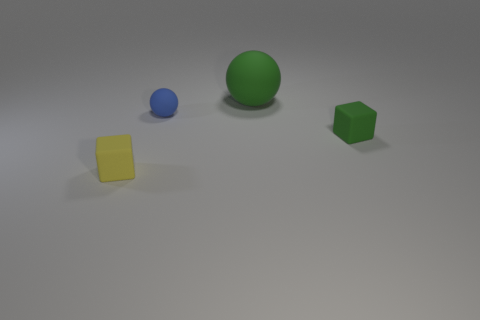Are there any other rubber things of the same color as the large rubber object?
Offer a very short reply. Yes. Is the number of small green matte things left of the small green object less than the number of objects that are behind the large green rubber thing?
Provide a short and direct response. No. What is the shape of the small yellow object that is made of the same material as the green ball?
Your answer should be compact. Cube. How big is the block behind the block that is in front of the green matte object that is in front of the tiny blue object?
Your response must be concise. Small. Are there more tiny purple things than tiny green cubes?
Provide a succinct answer. No. Do the small block that is right of the small yellow matte cube and the ball in front of the large matte thing have the same color?
Ensure brevity in your answer.  No. Do the tiny thing in front of the tiny green block and the small cube behind the yellow matte block have the same material?
Provide a short and direct response. Yes. How many green matte cubes have the same size as the blue matte sphere?
Your response must be concise. 1. Is the number of tiny red matte balls less than the number of big matte things?
Provide a short and direct response. Yes. What shape is the small blue thing behind the tiny matte block on the right side of the blue rubber thing?
Ensure brevity in your answer.  Sphere. 